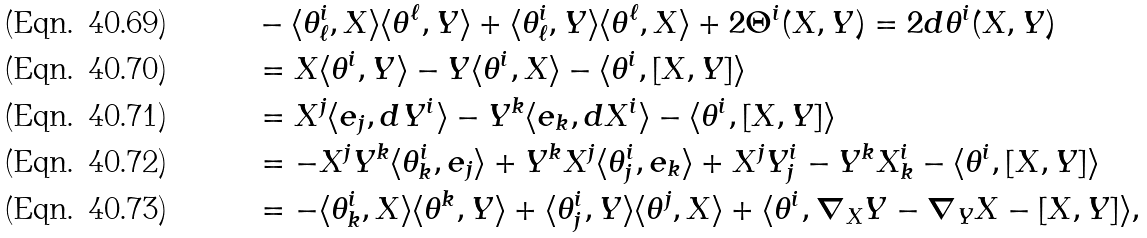Convert formula to latex. <formula><loc_0><loc_0><loc_500><loc_500>& - \langle \theta ^ { i } _ { \ell } , X \rangle \langle \theta ^ { \ell } , Y \rangle + \langle \theta ^ { i } _ { \ell } , Y \rangle \langle \theta ^ { \ell } , X \rangle + 2 \Theta ^ { i } ( X , Y ) = 2 d \theta ^ { i } ( X , Y ) \\ & = X \langle \theta ^ { i } , Y \rangle - Y \langle \theta ^ { i } , X \rangle - \langle \theta ^ { i } , [ X , Y ] \rangle \\ & = X ^ { j } \langle e _ { j } , d Y ^ { i } \rangle - Y ^ { k } \langle e _ { k } , d X ^ { i } \rangle - \langle \theta ^ { i } , [ X , Y ] \rangle \\ & = - X ^ { j } Y ^ { k } \langle \theta ^ { i } _ { k } , e _ { j } \rangle + Y ^ { k } X ^ { j } \langle \theta ^ { i } _ { j } , e _ { k } \rangle + X ^ { j } Y ^ { i } _ { j } - Y ^ { k } X ^ { i } _ { k } - \langle \theta ^ { i } , [ X , Y ] \rangle \\ & = - \langle \theta ^ { i } _ { k } , X \rangle \langle \theta ^ { k } , Y \rangle + \langle \theta ^ { i } _ { j } , Y \rangle \langle \theta ^ { j } , X \rangle + \langle \theta ^ { i } , \nabla _ { X } Y - \nabla _ { Y } X - [ X , Y ] \rangle ,</formula> 